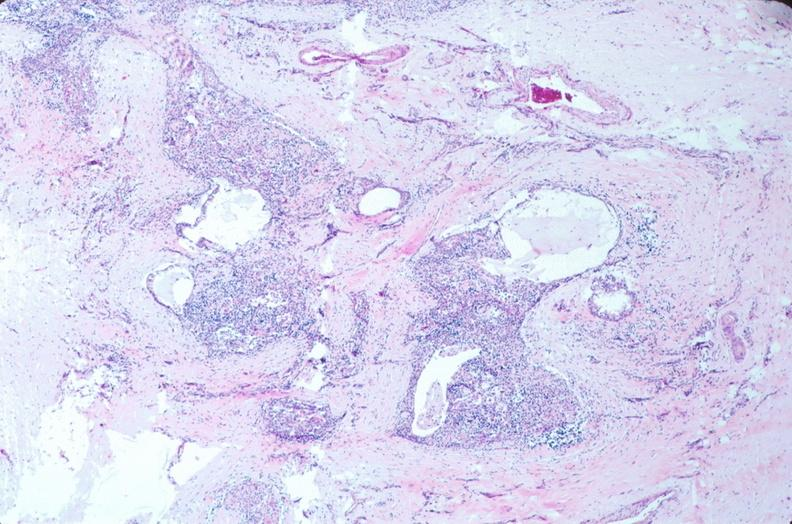does this image show pharyngeal pouch remnant, incidental finding in an adult?
Answer the question using a single word or phrase. Yes 